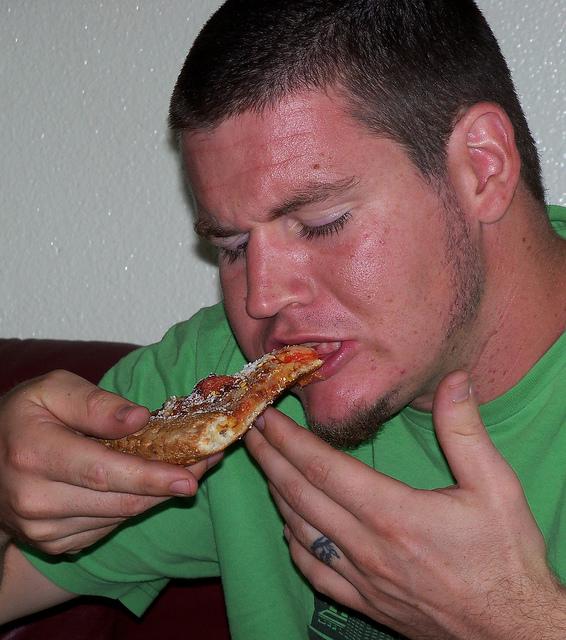What type of crust does this pizza have?
Quick response, please. Thin. What is the man eating?
Be succinct. Pizza. Will this man eat until he's full?
Answer briefly. Yes. 